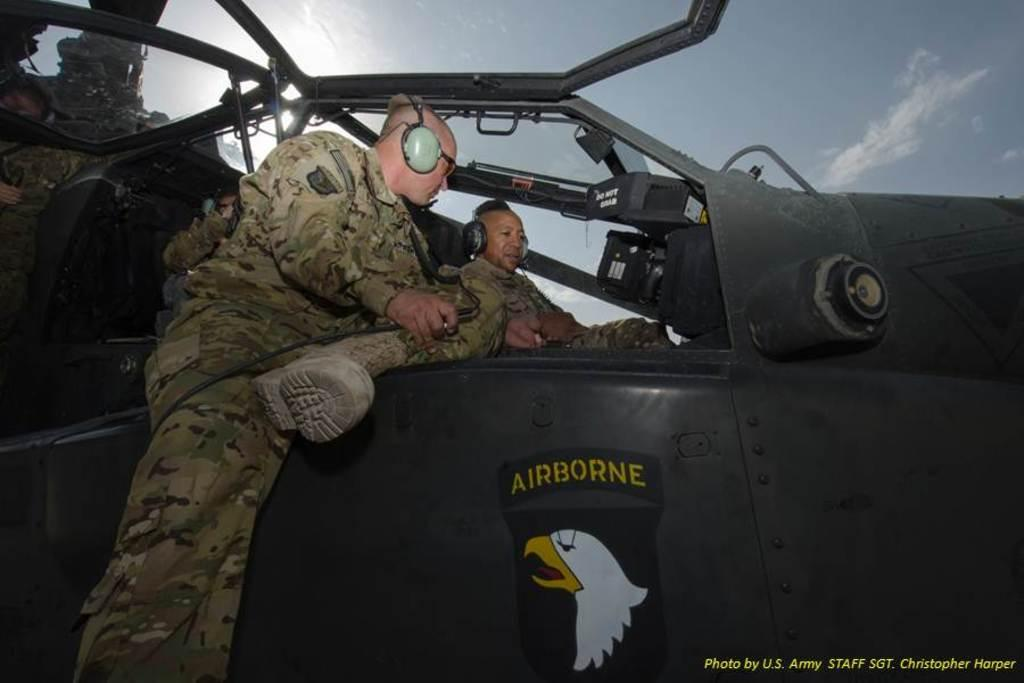<image>
Create a compact narrative representing the image presented. Two soldiers sit on on a plane that has a picture of an eagle on the side and says Airborne above it. 